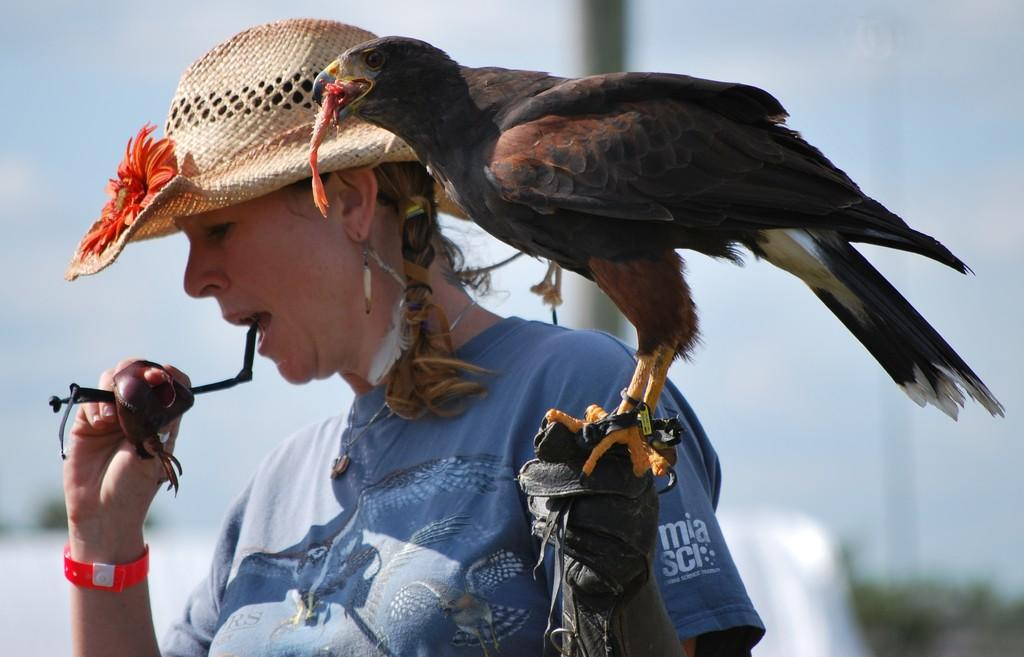What is the main subject of the image? There is a woman in the image. What is the woman holding in the image? The woman is holding an insect. What else can be seen in the image besides the woman? There is a bird in the image. What is the bird doing in the image? The bird is holding food. Can you describe the background of the image? The background of the image is blurred. What book is the woman reading in the image? There is no book present in the image; the woman is holding an insect. What type of knowledge does the bird possess about the food it is holding? The image does not provide information about the bird's knowledge or understanding of the food it is holding. 